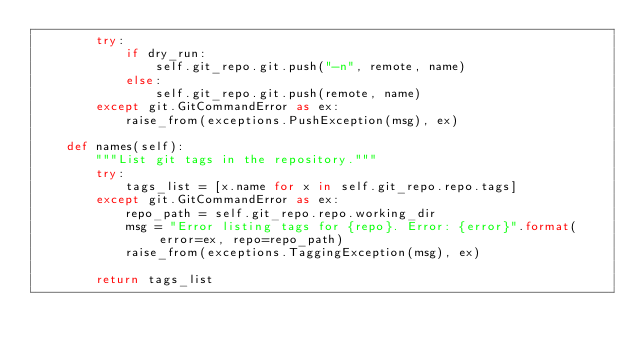<code> <loc_0><loc_0><loc_500><loc_500><_Python_>        try:
            if dry_run:
                self.git_repo.git.push("-n", remote, name)
            else:
                self.git_repo.git.push(remote, name)
        except git.GitCommandError as ex:
            raise_from(exceptions.PushException(msg), ex)

    def names(self):
        """List git tags in the repository."""
        try:
            tags_list = [x.name for x in self.git_repo.repo.tags]
        except git.GitCommandError as ex:
            repo_path = self.git_repo.repo.working_dir
            msg = "Error listing tags for {repo}. Error: {error}".format(error=ex, repo=repo_path)
            raise_from(exceptions.TaggingException(msg), ex)

        return tags_list
</code> 